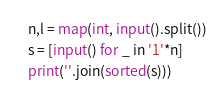Convert code to text. <code><loc_0><loc_0><loc_500><loc_500><_Python_>n,l = map(int, input().split())
s = [input() for _ in '1'*n]
print(''.join(sorted(s)))</code> 